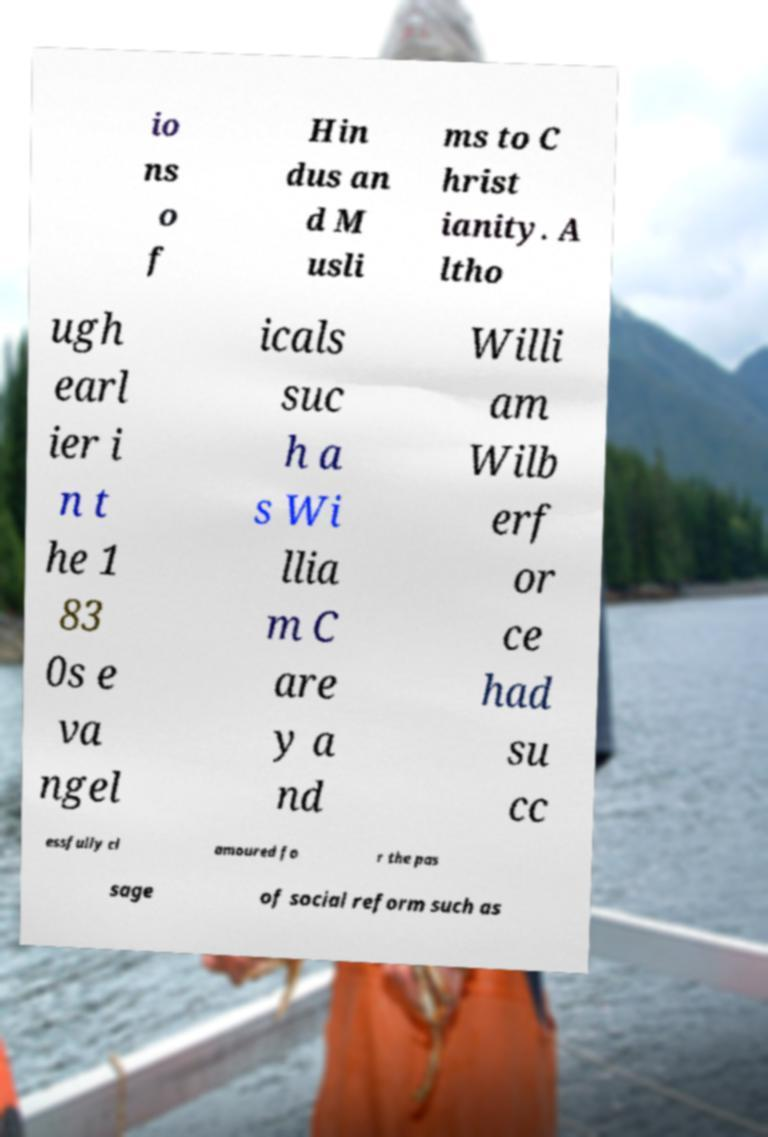Please read and relay the text visible in this image. What does it say? io ns o f Hin dus an d M usli ms to C hrist ianity. A ltho ugh earl ier i n t he 1 83 0s e va ngel icals suc h a s Wi llia m C are y a nd Willi am Wilb erf or ce had su cc essfully cl amoured fo r the pas sage of social reform such as 